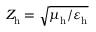<formula> <loc_0><loc_0><loc_500><loc_500>Z _ { h } = \sqrt { \mu _ { h } / \varepsilon _ { h } }</formula> 